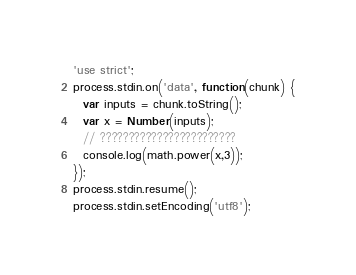Convert code to text. <code><loc_0><loc_0><loc_500><loc_500><_JavaScript_>'use strict';
process.stdin.on('data', function(chunk) {
  var inputs = chunk.toString();
  var x = Number(inputs);
  // ????????????????????????
  console.log(math.power(x,3));
});
process.stdin.resume();
process.stdin.setEncoding('utf8');</code> 